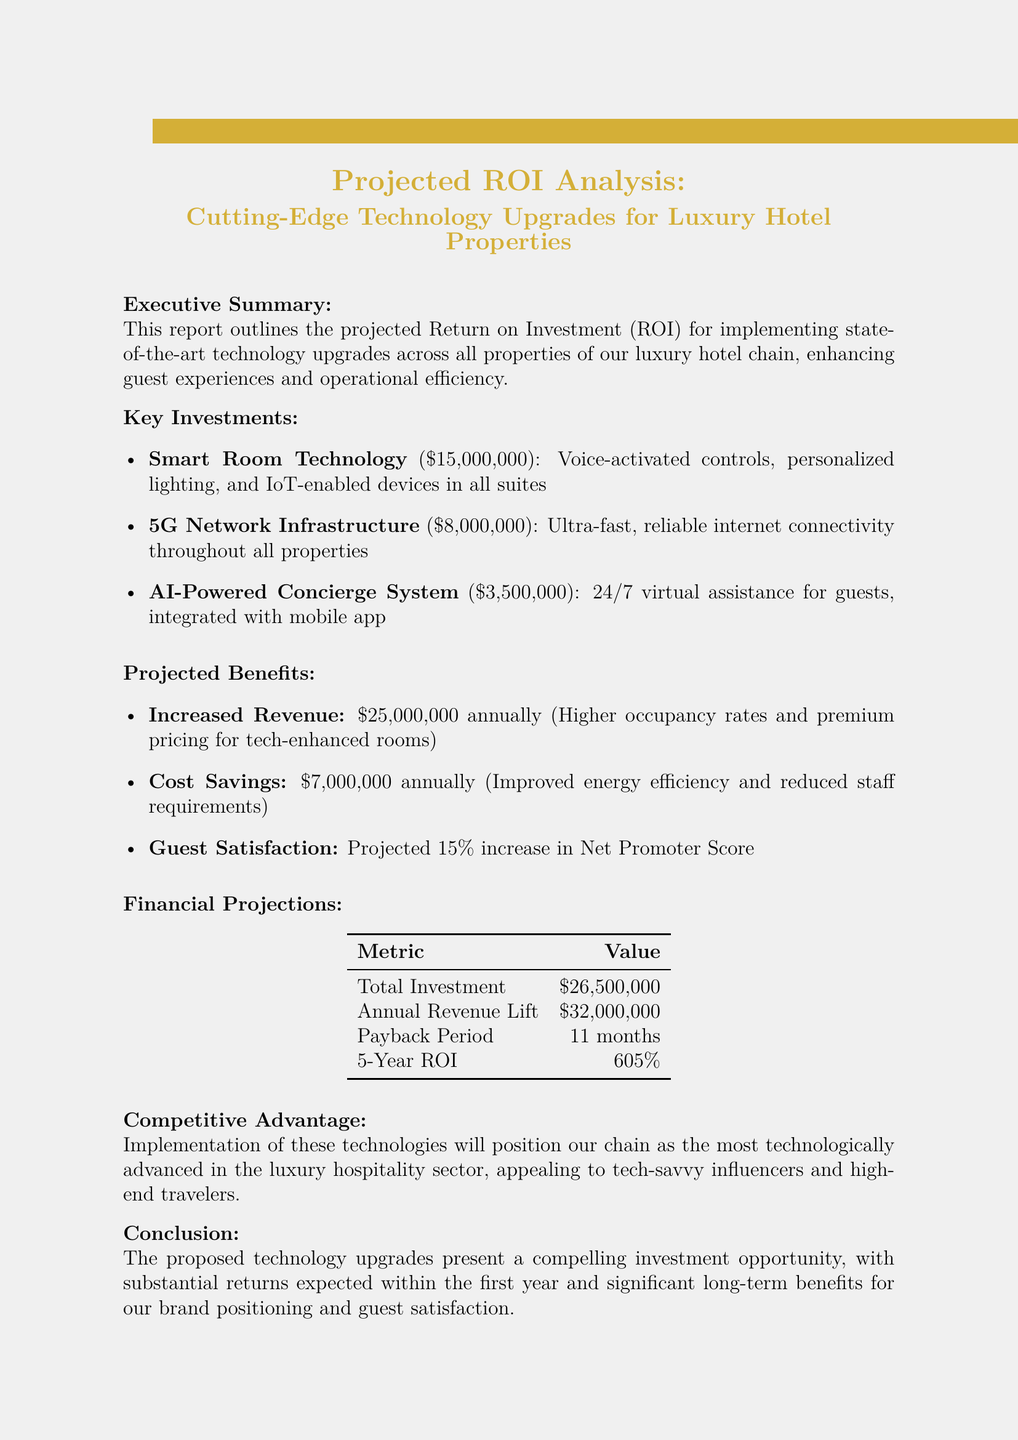What is the title of the report? The title is stated prominently at the beginning of the document.
Answer: Projected ROI Analysis: Cutting-Edge Technology Upgrades for Luxury Hotel Properties What is the total investment amount? The total investment is listed under financial projections in the report.
Answer: $26,500,000 What technology upgrade costs $15,000,000? The costs of each key investment are specified in the key investments section.
Answer: Smart Room Technology What is the projected annual revenue lift? This figure is included in the financial projections section of the document.
Answer: $32,000,000 What is the payback period for the investment? The payback period is explicitly mentioned in the financial projections.
Answer: 11 months What percentage increase is expected in the Net Promoter Score? This metric is listed under projected benefits and indicates expected customer satisfaction.
Answer: 15% What are the total projected cost savings annually? Cost savings are summarized in the projected benefits section.
Answer: $7,000,000 What is the five-year ROI percentage? The five-year ROI is noted under financial projections in the report.
Answer: 605% How will the technology upgrades position the hotel chain? This advantage is described under the competitive advantage section of the report.
Answer: Most technologically advanced in the luxury hospitality sector What is the main conclusion of the report? The conclusion summarizes the overall findings and expectations of the proposed upgrades.
Answer: Compelling investment opportunity 